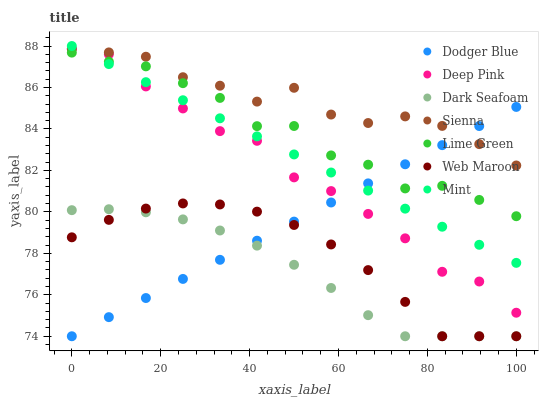Does Dark Seafoam have the minimum area under the curve?
Answer yes or no. Yes. Does Sienna have the maximum area under the curve?
Answer yes or no. Yes. Does Mint have the minimum area under the curve?
Answer yes or no. No. Does Mint have the maximum area under the curve?
Answer yes or no. No. Is Mint the smoothest?
Answer yes or no. Yes. Is Lime Green the roughest?
Answer yes or no. Yes. Is Web Maroon the smoothest?
Answer yes or no. No. Is Web Maroon the roughest?
Answer yes or no. No. Does Web Maroon have the lowest value?
Answer yes or no. Yes. Does Mint have the lowest value?
Answer yes or no. No. Does Mint have the highest value?
Answer yes or no. Yes. Does Web Maroon have the highest value?
Answer yes or no. No. Is Lime Green less than Sienna?
Answer yes or no. Yes. Is Deep Pink greater than Web Maroon?
Answer yes or no. Yes. Does Web Maroon intersect Dark Seafoam?
Answer yes or no. Yes. Is Web Maroon less than Dark Seafoam?
Answer yes or no. No. Is Web Maroon greater than Dark Seafoam?
Answer yes or no. No. Does Lime Green intersect Sienna?
Answer yes or no. No. 